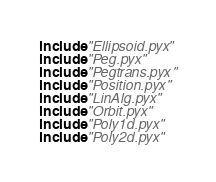Convert code to text. <code><loc_0><loc_0><loc_500><loc_500><_Cython_>include "Ellipsoid.pyx"
include "Peg.pyx"
include "Pegtrans.pyx"
include "Position.pyx"
include "LinAlg.pyx"
include "Orbit.pyx"
include "Poly1d.pyx"
include "Poly2d.pyx"
</code> 